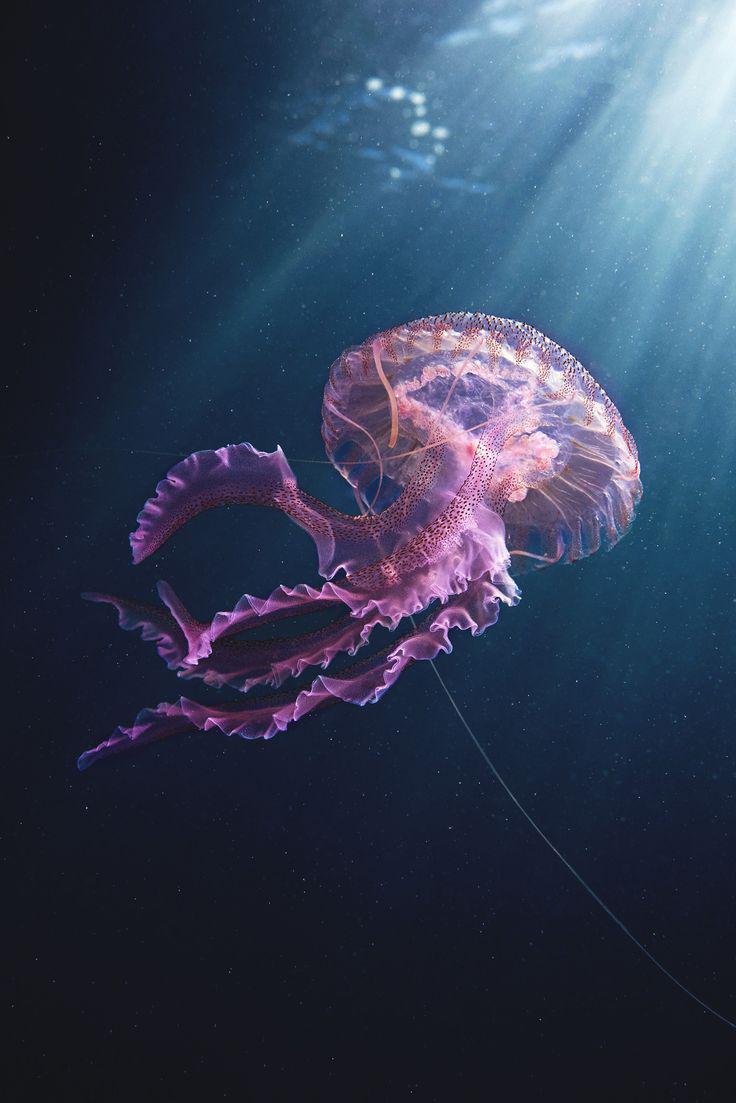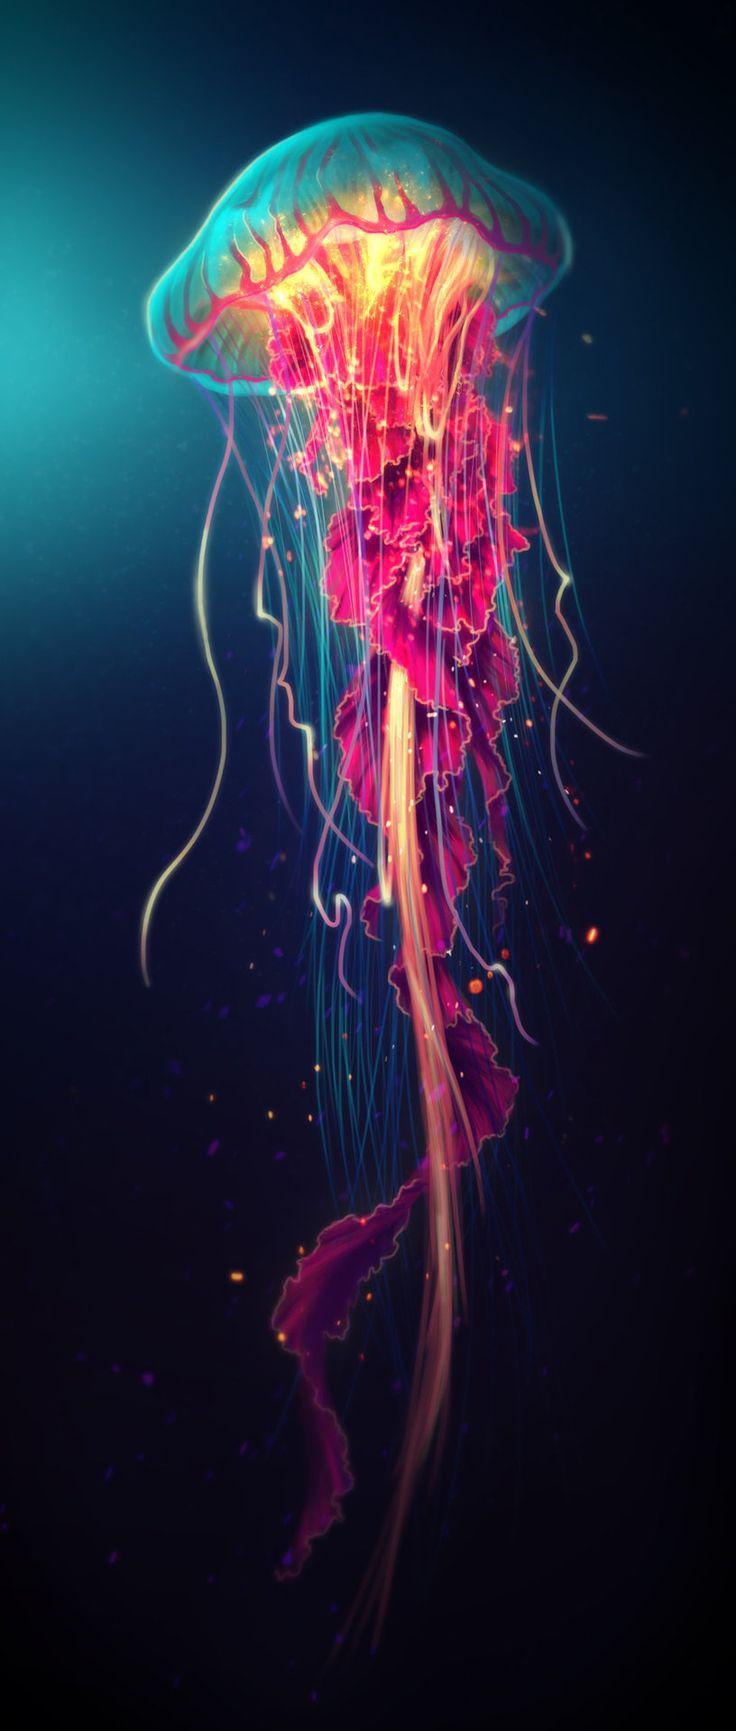The first image is the image on the left, the second image is the image on the right. Assess this claim about the two images: "Exactly one image shows multiple hot pink jellyfish on a blue backdrop.". Correct or not? Answer yes or no. No. The first image is the image on the left, the second image is the image on the right. Considering the images on both sides, is "There is a single upright jellyfish in one of the images." valid? Answer yes or no. Yes. 